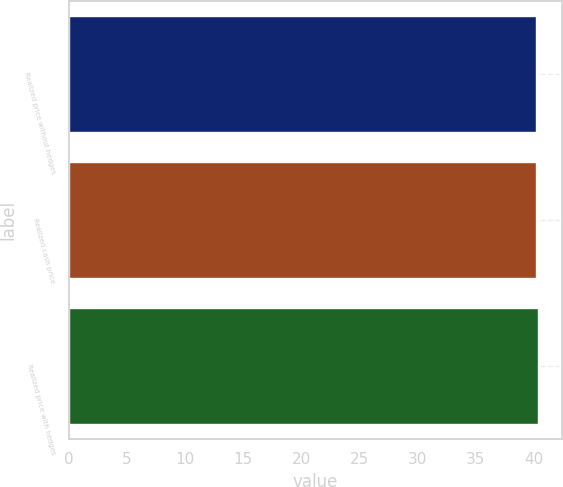Convert chart. <chart><loc_0><loc_0><loc_500><loc_500><bar_chart><fcel>Realized price without hedges<fcel>Realized cash price<fcel>Realized price with hedges<nl><fcel>40.19<fcel>40.21<fcel>40.38<nl></chart> 